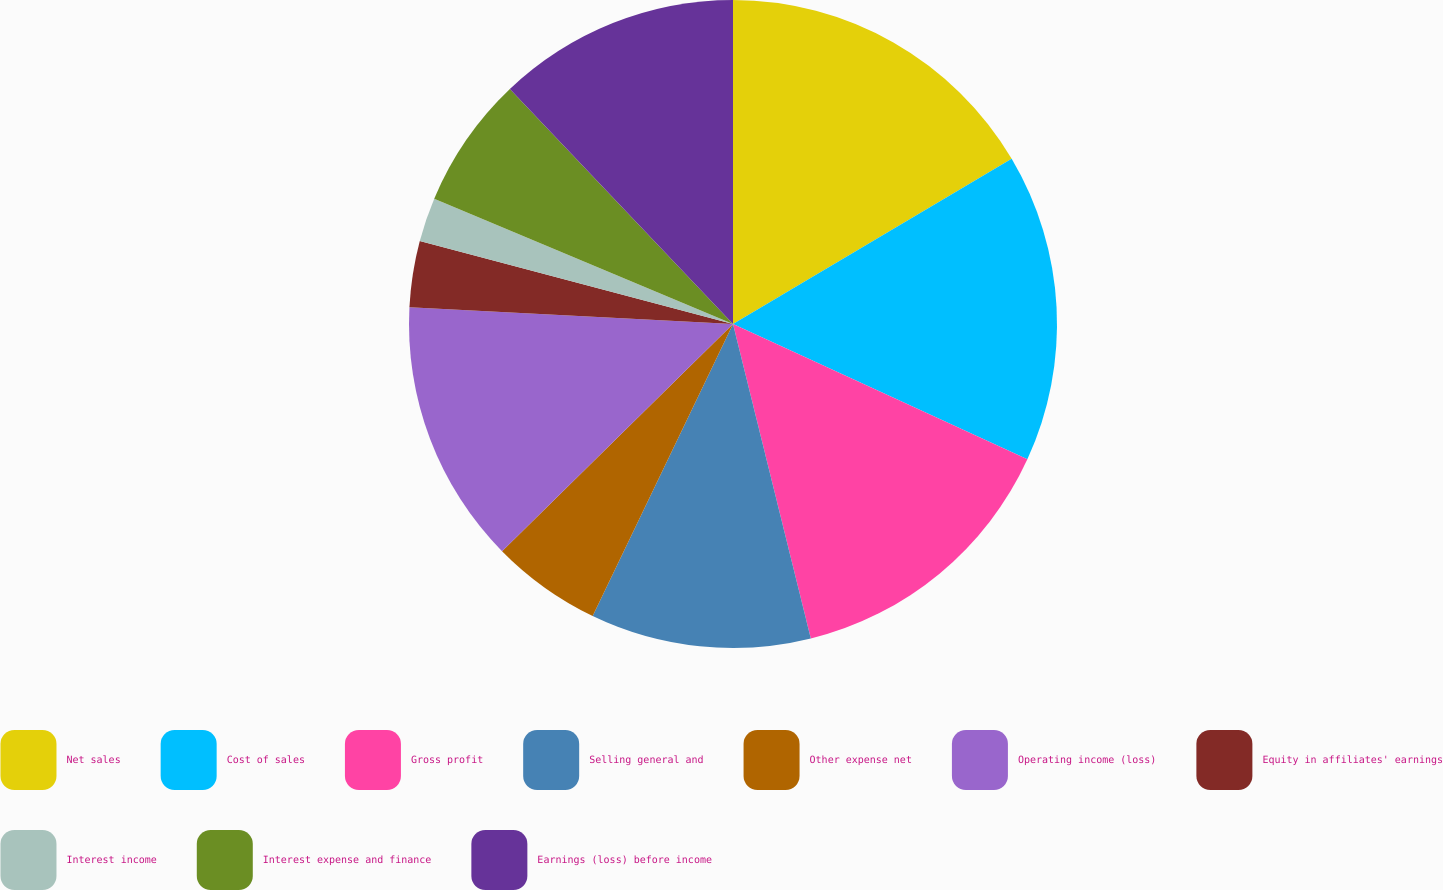Convert chart to OTSL. <chart><loc_0><loc_0><loc_500><loc_500><pie_chart><fcel>Net sales<fcel>Cost of sales<fcel>Gross profit<fcel>Selling general and<fcel>Other expense net<fcel>Operating income (loss)<fcel>Equity in affiliates' earnings<fcel>Interest income<fcel>Interest expense and finance<fcel>Earnings (loss) before income<nl><fcel>16.48%<fcel>15.38%<fcel>14.28%<fcel>10.99%<fcel>5.5%<fcel>13.19%<fcel>3.3%<fcel>2.2%<fcel>6.59%<fcel>12.09%<nl></chart> 